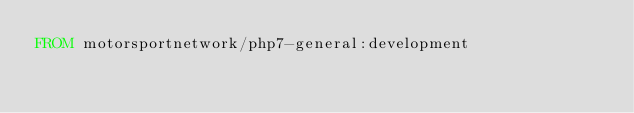<code> <loc_0><loc_0><loc_500><loc_500><_Dockerfile_>FROM motorsportnetwork/php7-general:development</code> 